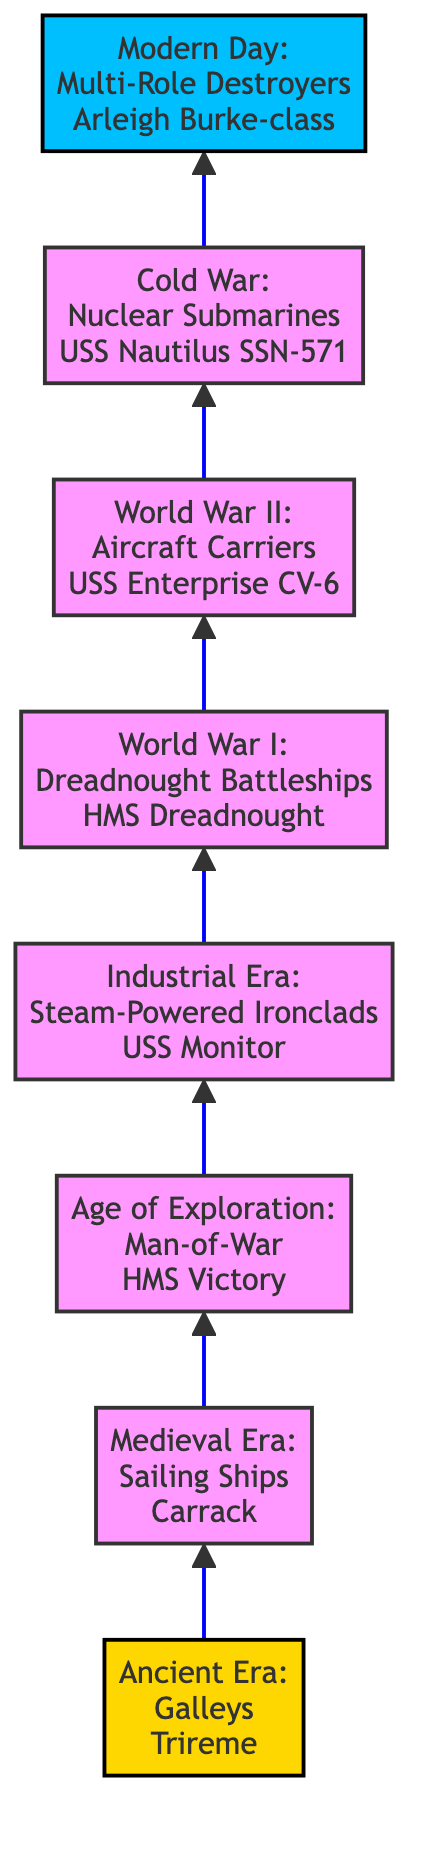What is the example vessel from the Ancient Era? In the diagram, the node representing the Ancient Era mentions "Galleys" and specifically lists "Trireme" as an example vessel.
Answer: Trireme How many periods are represented in the flowchart? By counting the nodes in the diagram, we find there are eight periods mentioned, starting from Ancient Era to Modern Day.
Answer: 8 What type of warship became dominant during World War II? The World War II node specifies that "Aircraft Carriers" were the dominant vessels during that period.
Answer: Aircraft Carriers What is the first period of naval warfare development shown in the diagram? The flowchart starts with the "Ancient Era," indicating it as the first period.
Answer: Ancient Era Which naval vessel exemplifies the Industrial Era? The diagram notes "Steam-Powered Ironclads" along with "USS Monitor" as an example for that era.
Answer: USS Monitor What key advancement is associated with naval warfare in the Cold War? The Cold War node details "Nuclear Submarines" as a significant advancement in that time period.
Answer: Nuclear Submarines Which vessel type is described as "versatile warships" in the Modern Day? The Modern Day node mentions "Multi-Role Destroyers" and indicates their versatile capabilities.
Answer: Multi-Role Destroyers What was a significant feature of Dreadnought Battleships? The World War I entry defines Dreadnought Battleships as "all-big-gun battleships," marking their notable feature.
Answer: All-big-gun battleships What technological advancement characterized vessels in the Age of Exploration? In the Age of Exploration node, "Man-of-War" ships are highlighted, emphasizing their powerful cannon capabilities, which were a key advancement.
Answer: Powerful sailing warships 